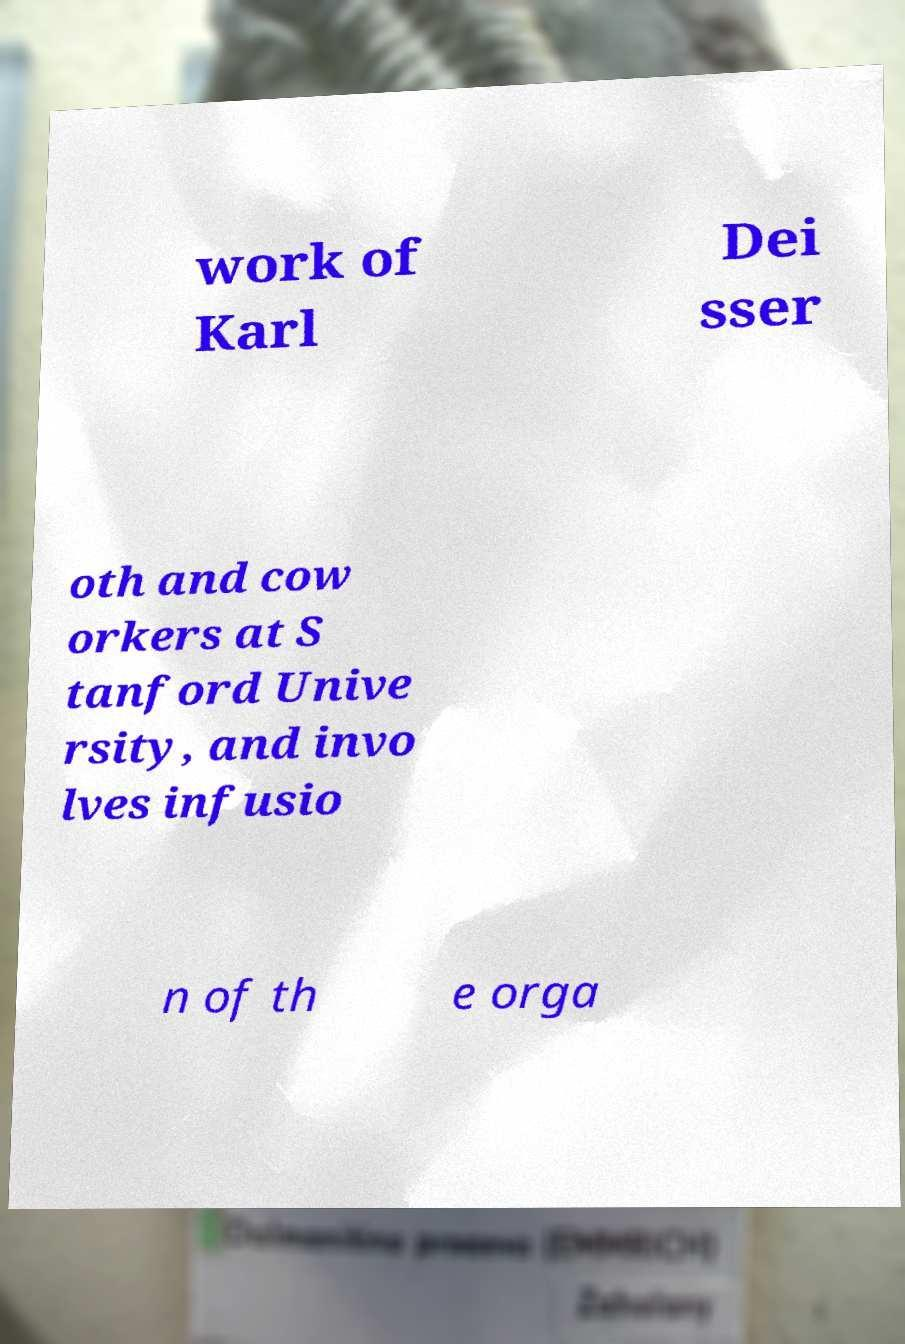For documentation purposes, I need the text within this image transcribed. Could you provide that? work of Karl Dei sser oth and cow orkers at S tanford Unive rsity, and invo lves infusio n of th e orga 